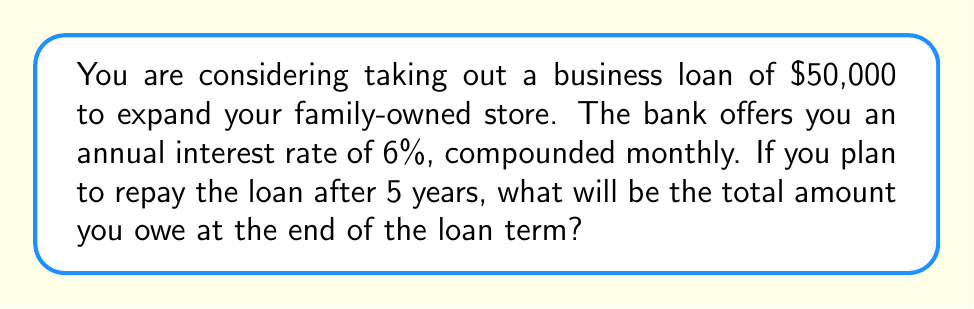Teach me how to tackle this problem. To solve this problem, we'll use the compound interest formula:

$$A = P(1 + \frac{r}{n})^{nt}$$

Where:
$A$ = final amount
$P$ = principal (initial loan amount)
$r$ = annual interest rate (as a decimal)
$n$ = number of times interest is compounded per year
$t$ = number of years

Given:
$P = \$50,000$
$r = 0.06$ (6% expressed as a decimal)
$n = 12$ (compounded monthly)
$t = 5$ years

Let's substitute these values into the formula:

$$A = 50000(1 + \frac{0.06}{12})^{12 \cdot 5}$$

Simplifying:
$$A = 50000(1 + 0.005)^{60}$$

$$A = 50000(1.005)^{60}$$

Using a calculator or computer:

$$A = 50000 \cdot 1.3489815$$

$$A = 67449.08$$

Therefore, the total amount owed after 5 years will be $67,449.08.
Answer: $67,449.08 